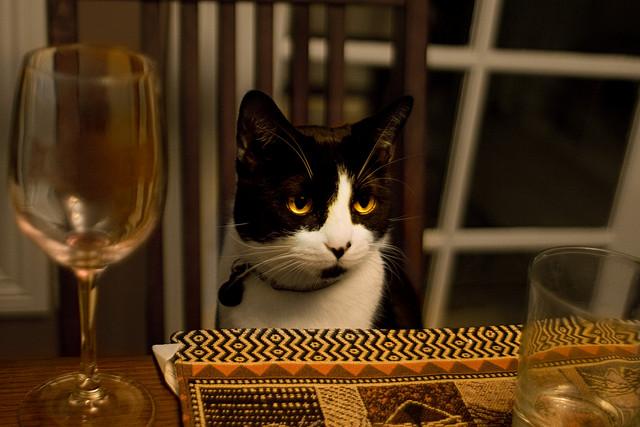Is the cat wearing a collar?
Answer briefly. Yes. What color is the cat's eyes?
Be succinct. Yellow. What is the glass to the left used for?
Give a very brief answer. Wine. 